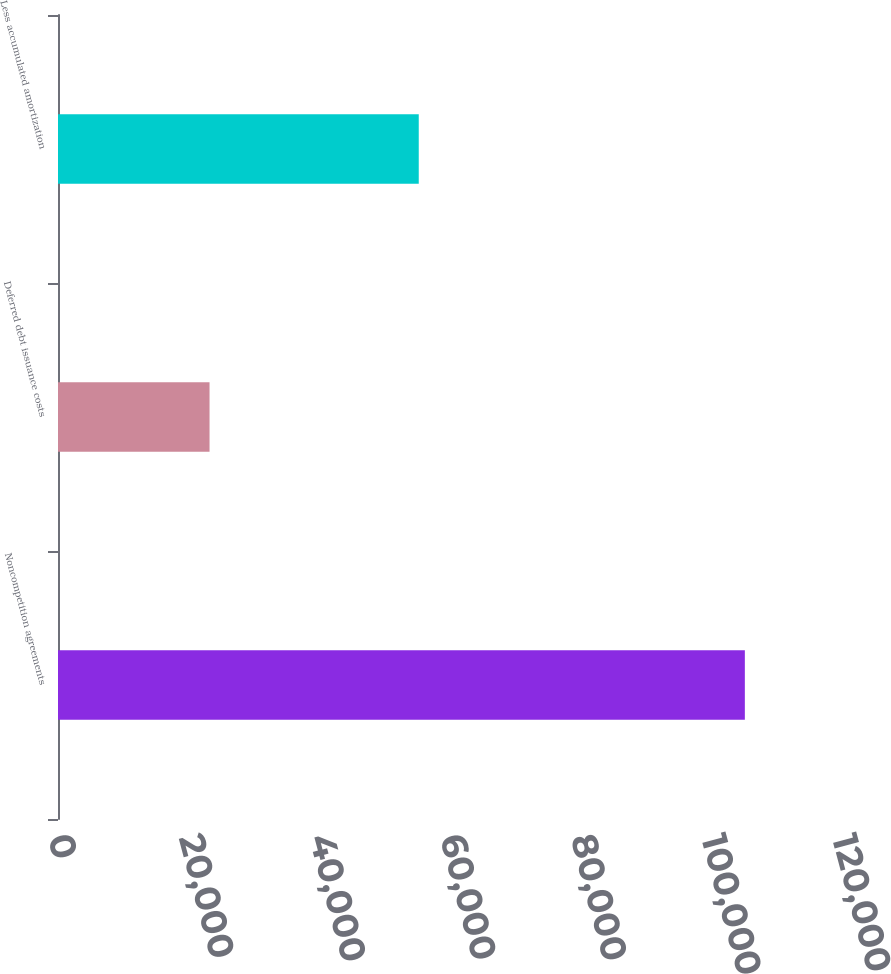Convert chart to OTSL. <chart><loc_0><loc_0><loc_500><loc_500><bar_chart><fcel>Noncompetition agreements<fcel>Deferred debt issuance costs<fcel>Less accumulated amortization<nl><fcel>105130<fcel>23195<fcel>55217<nl></chart> 